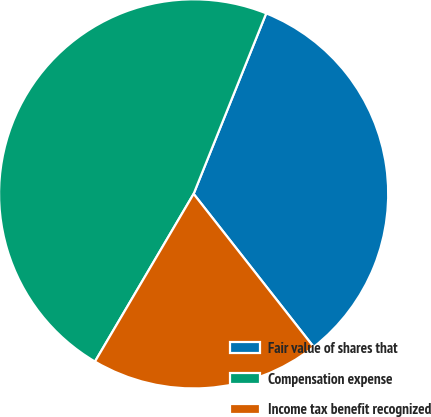Convert chart. <chart><loc_0><loc_0><loc_500><loc_500><pie_chart><fcel>Fair value of shares that<fcel>Compensation expense<fcel>Income tax benefit recognized<nl><fcel>33.33%<fcel>47.62%<fcel>19.05%<nl></chart> 